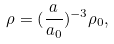<formula> <loc_0><loc_0><loc_500><loc_500>\rho = ( \frac { a } { a _ { 0 } } ) ^ { - 3 } \rho _ { 0 } ,</formula> 